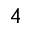<formula> <loc_0><loc_0><loc_500><loc_500>^ { 4 }</formula> 